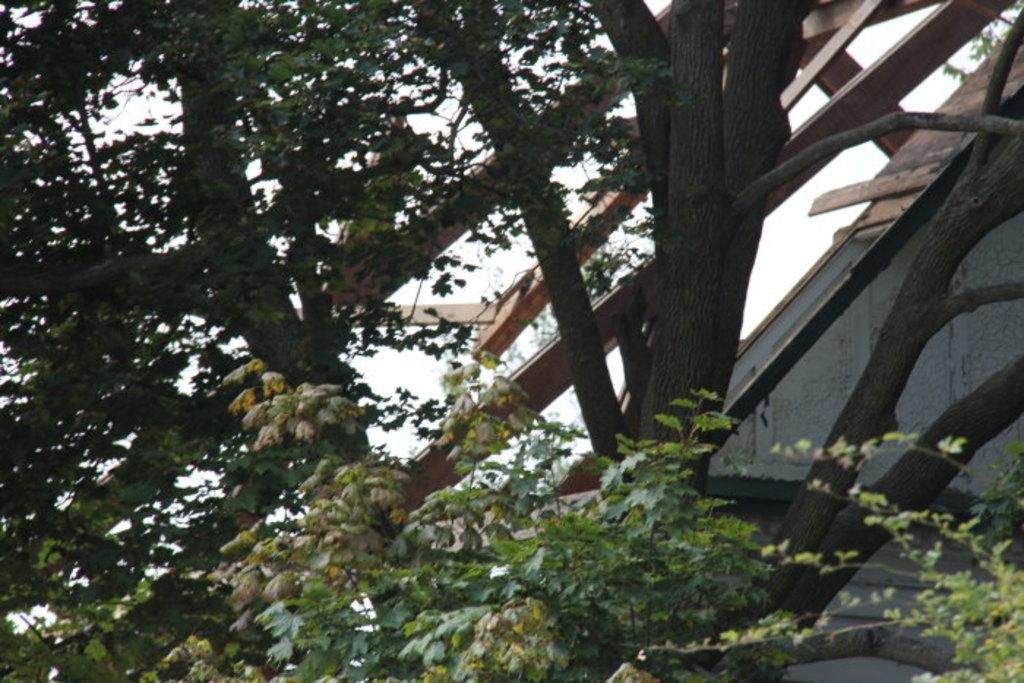What type of vegetation can be seen in the image? There are trees in the image. What is the color of the trees in the image? The trees are green in color. What else is visible in the image besides the trees? The sky is visible in the image. What is the color of the sky in the image? The sky is white in color. What objects made of wood can be seen in the image? There are wooden sticks in the image. Can you tell me how many boots are hanging from the trees in the image? There are no boots present in the image; it only features trees, a white sky, and wooden sticks. 